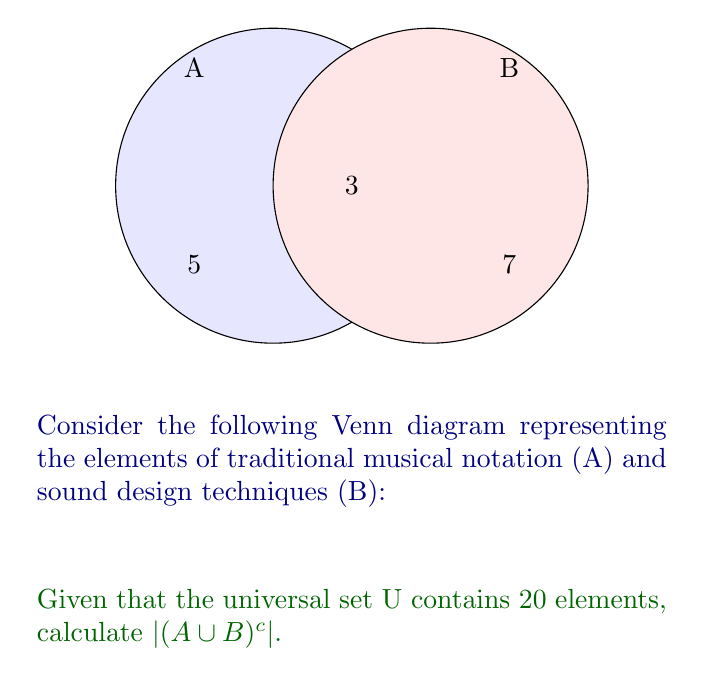Solve this math problem. Let's approach this step-by-step:

1) First, we need to understand what the question is asking:
   $|(A \cup B)^c|$ represents the cardinality (number of elements) of the complement of the union of sets A and B.

2) From the Venn diagram, we can see:
   - $|A \setminus B| = 5$ (elements only in A)
   - $|A \cap B| = 3$ (elements in both A and B)
   - $|B \setminus A| = 7$ (elements only in B)

3) To find $|A \cup B|$, we add these up:
   $|A \cup B| = 5 + 3 + 7 = 15$

4) The universal set U has 20 elements, so:
   $|(A \cup B)^c| = |U| - |A \cup B| = 20 - 15 = 5$

This result shows that there are 5 elements in the universal set that are neither in traditional musical notation nor in sound design techniques.
Answer: 5 